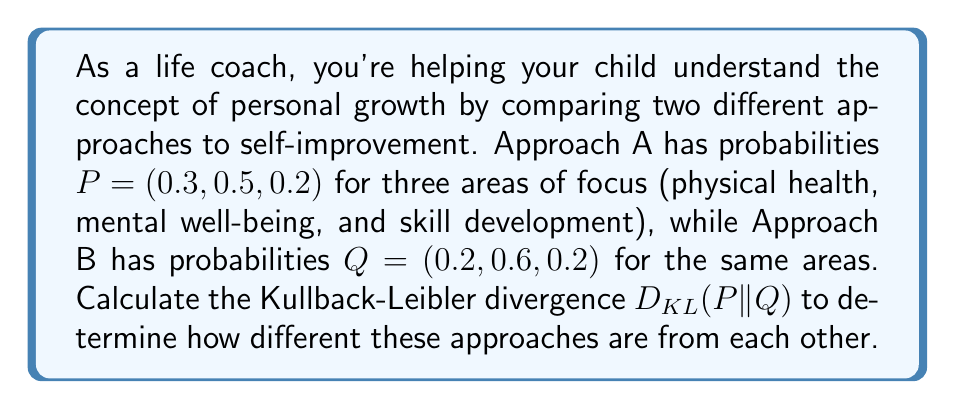Show me your answer to this math problem. To calculate the Kullback-Leibler divergence between probability distributions P and Q, we use the formula:

$$D_{KL}(P||Q) = \sum_{i} P(i) \log_2 \frac{P(i)}{Q(i)}$$

Let's break this down step-by-step:

1) For each probability in P, we need to calculate $P(i) \log_2 \frac{P(i)}{Q(i)}$:

   For i = 1: $0.3 \log_2 \frac{0.3}{0.2}$
   For i = 2: $0.5 \log_2 \frac{0.5}{0.6}$
   For i = 3: $0.2 \log_2 \frac{0.2}{0.2}$

2) Let's calculate each term:

   $0.3 \log_2 \frac{0.3}{0.2} = 0.3 \log_2 1.5 = 0.3 * 0.5850 = 0.1755$
   $0.5 \log_2 \frac{0.5}{0.6} = 0.5 \log_2 0.8333 = 0.5 * (-0.2630) = -0.1315$
   $0.2 \log_2 \frac{0.2}{0.2} = 0.2 \log_2 1 = 0$

3) Now, we sum these values:

   $D_{KL}(P||Q) = 0.1755 + (-0.1315) + 0 = 0.0440$

This value represents the relative entropy or information gain when using P instead of Q. A lower value indicates that the distributions are more similar.
Answer: The Kullback-Leibler divergence $D_{KL}(P||Q)$ is approximately 0.0440 bits. 